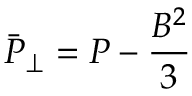Convert formula to latex. <formula><loc_0><loc_0><loc_500><loc_500>\bar { P } _ { \perp } = P - \frac { { B } ^ { 2 } } { 3 }</formula> 